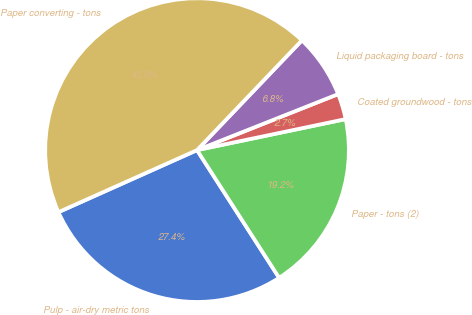Convert chart to OTSL. <chart><loc_0><loc_0><loc_500><loc_500><pie_chart><fcel>Pulp - air-dry metric tons<fcel>Paper - tons (2)<fcel>Coated groundwood - tons<fcel>Liquid packaging board - tons<fcel>Paper converting - tons<nl><fcel>27.4%<fcel>19.18%<fcel>2.74%<fcel>6.85%<fcel>43.84%<nl></chart> 